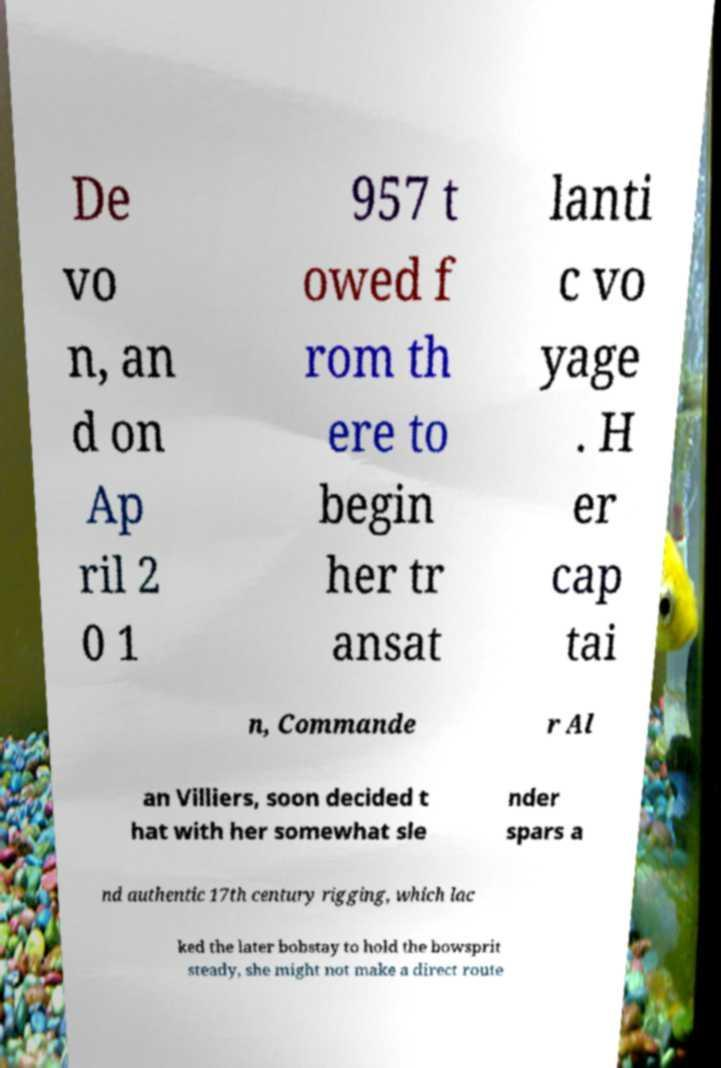Please read and relay the text visible in this image. What does it say? De vo n, an d on Ap ril 2 0 1 957 t owed f rom th ere to begin her tr ansat lanti c vo yage . H er cap tai n, Commande r Al an Villiers, soon decided t hat with her somewhat sle nder spars a nd authentic 17th century rigging, which lac ked the later bobstay to hold the bowsprit steady, she might not make a direct route 